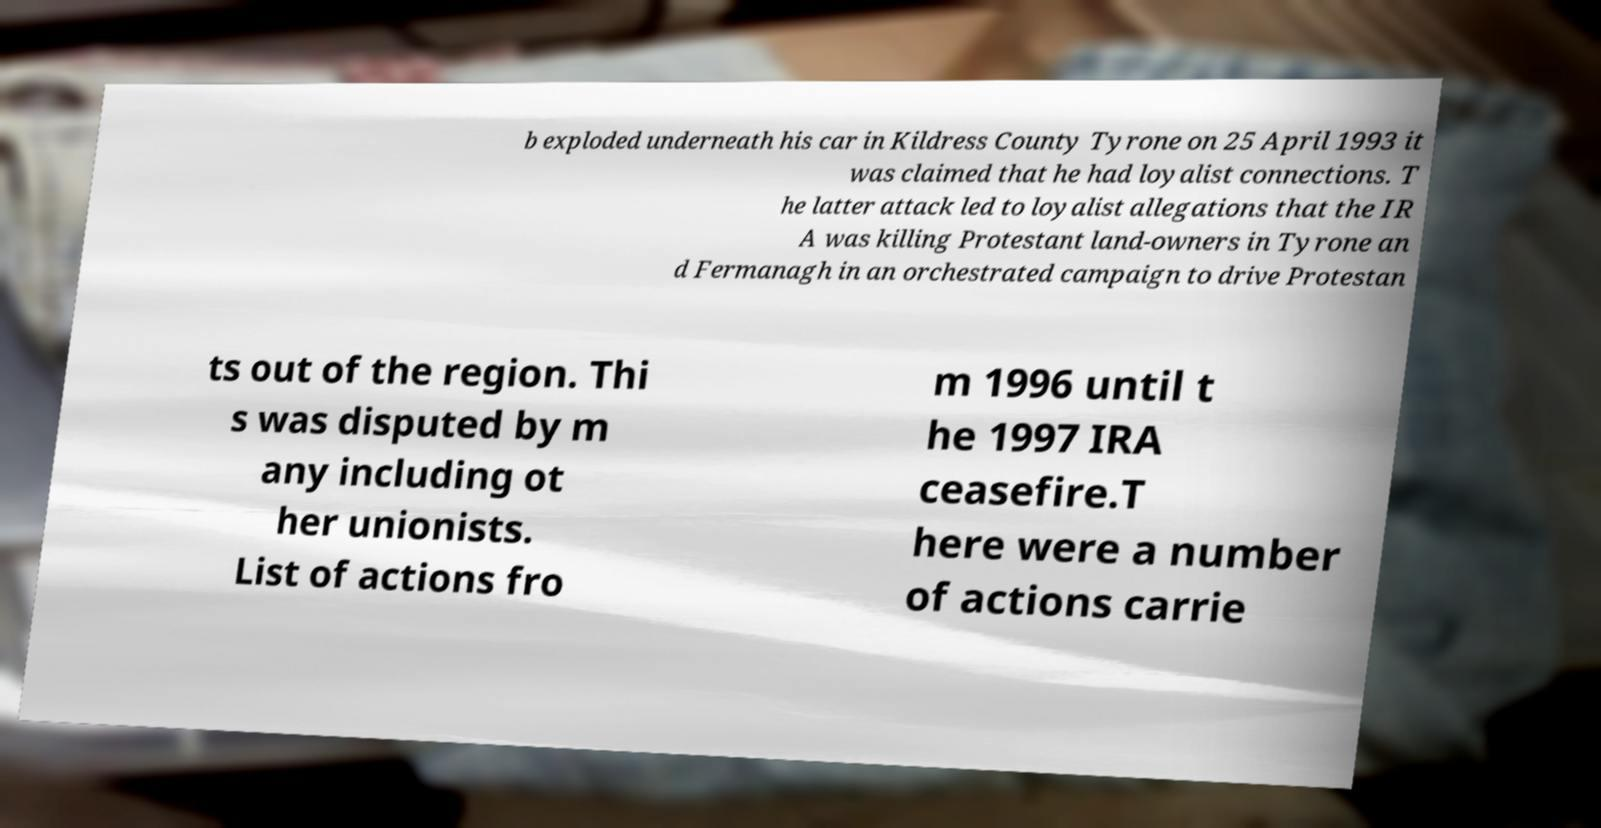Could you extract and type out the text from this image? b exploded underneath his car in Kildress County Tyrone on 25 April 1993 it was claimed that he had loyalist connections. T he latter attack led to loyalist allegations that the IR A was killing Protestant land-owners in Tyrone an d Fermanagh in an orchestrated campaign to drive Protestan ts out of the region. Thi s was disputed by m any including ot her unionists. List of actions fro m 1996 until t he 1997 IRA ceasefire.T here were a number of actions carrie 